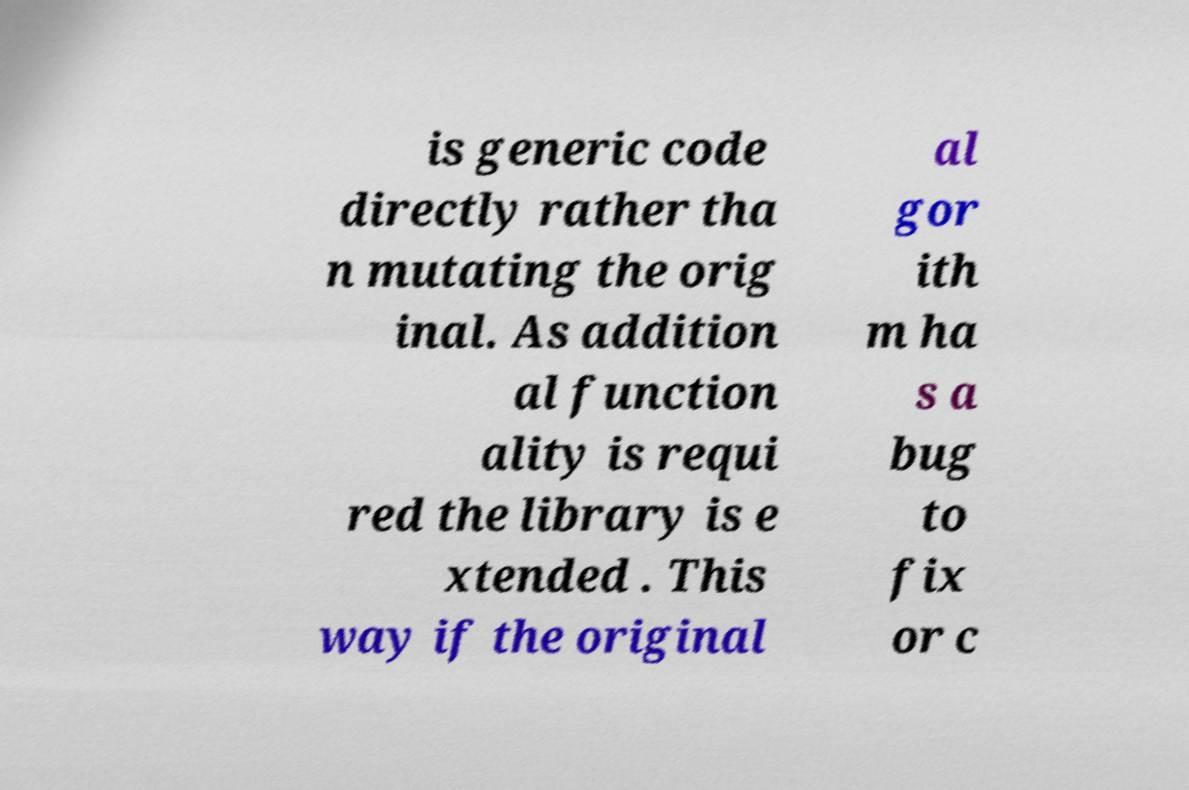There's text embedded in this image that I need extracted. Can you transcribe it verbatim? is generic code directly rather tha n mutating the orig inal. As addition al function ality is requi red the library is e xtended . This way if the original al gor ith m ha s a bug to fix or c 